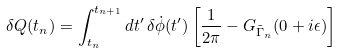<formula> <loc_0><loc_0><loc_500><loc_500>\delta Q ( t _ { n } ) = \int _ { t _ { n } } ^ { t _ { n + 1 } } d t ^ { \prime } \, \delta \dot { \phi } ( t ^ { \prime } ) \left [ \frac { 1 } { 2 \pi } - G _ { \tilde { \Gamma } _ { n } } ( 0 + i \epsilon ) \right ]</formula> 